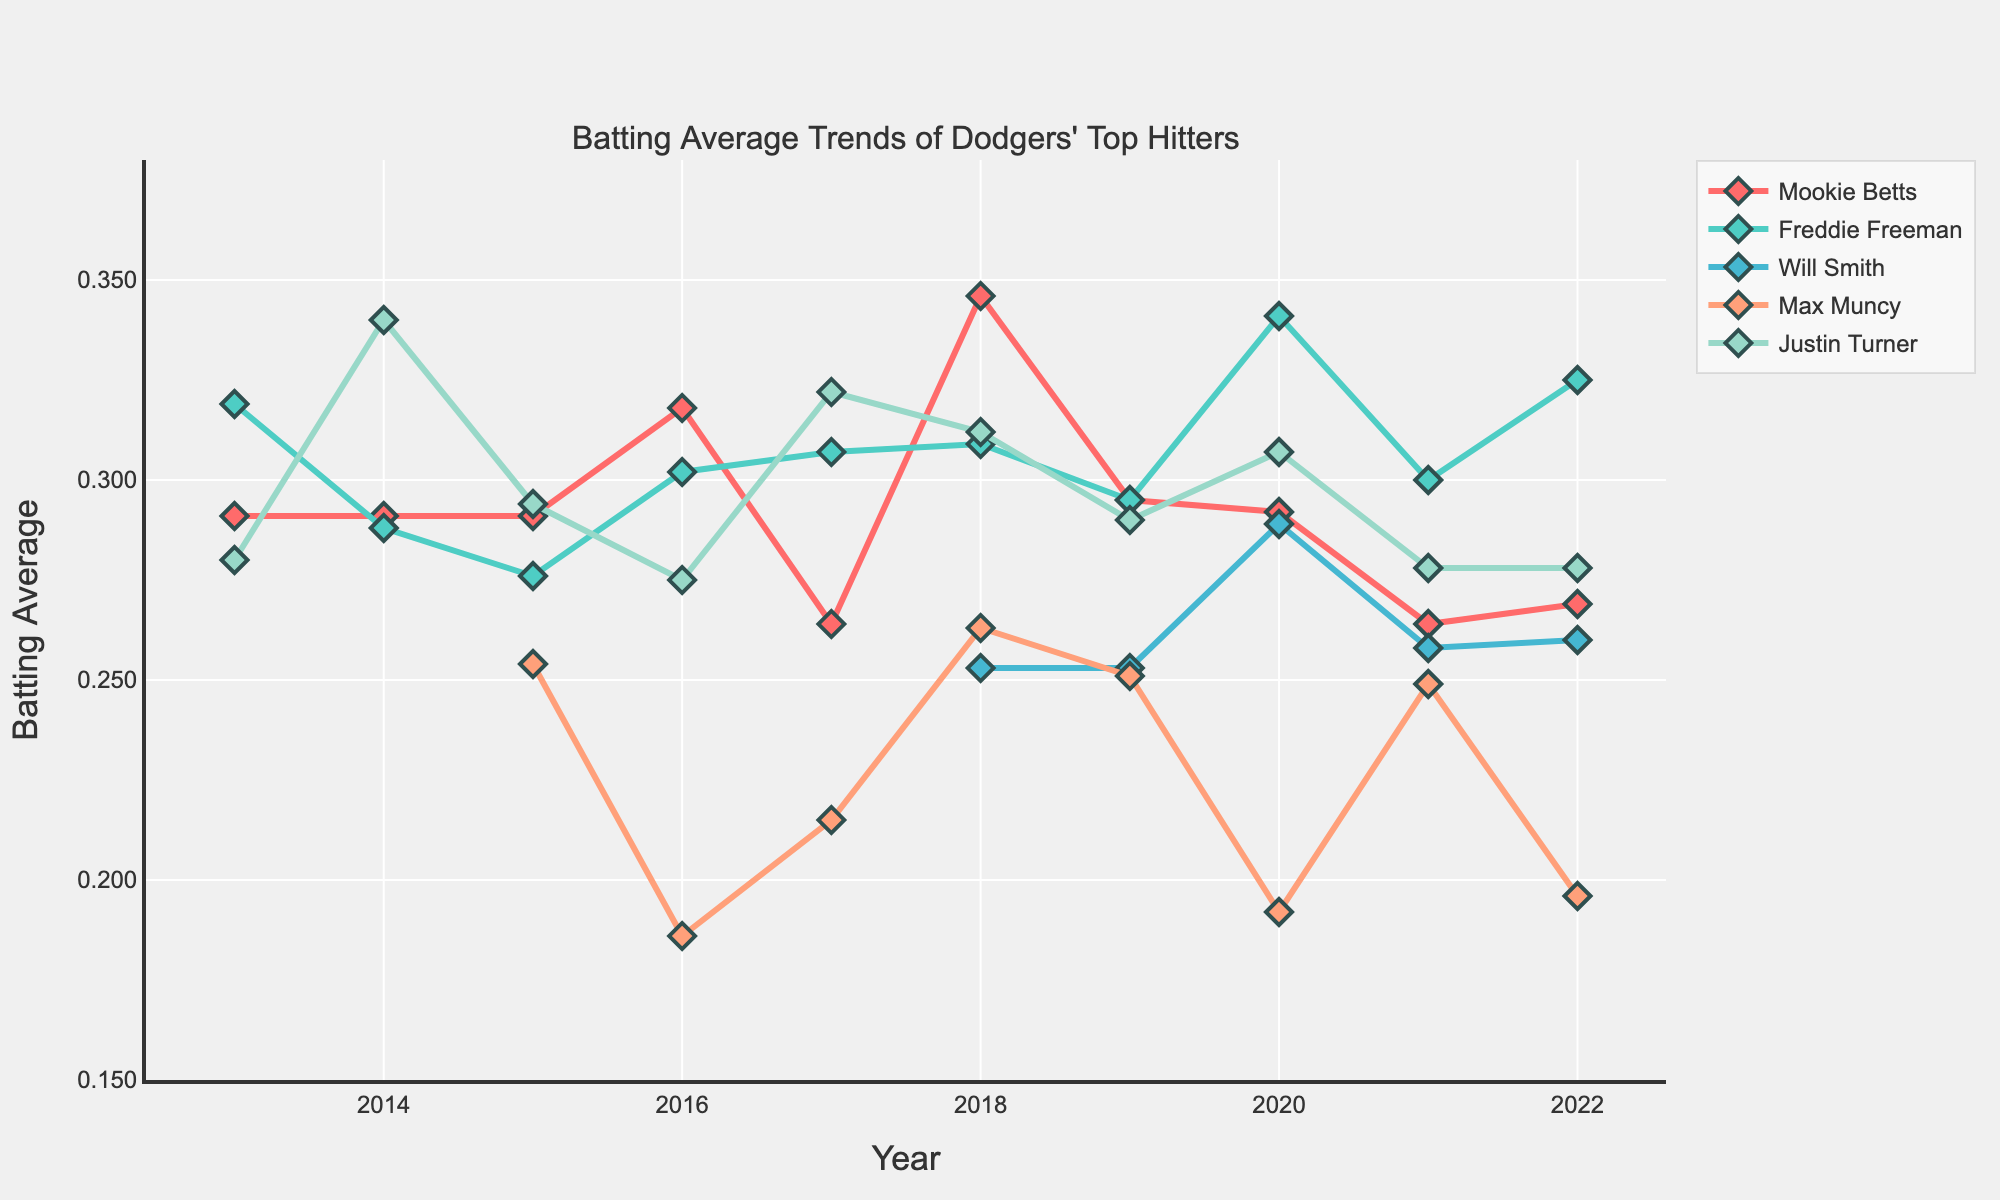What is the trend of Freddie Freeman's batting average over the past 10 seasons? To determine the trend, observe Freddie Freeman's batting average from 2013 to 2022. His average starts at 0.319 in 2013, fluctuating slightly but generally showing an upward trend, especially notable in 2020 where he reaches 0.341.
Answer: Generally increasing In which year did Max Muncy have the lowest batting average? By tracing the line corresponding to Max Muncy, it can be seen that 2016 has the lowest batting average of 0.186.
Answer: 2016 How does Mookie Betts’ average in 2018 compare to his average in 2022? Mookie Betts' average in 2018 is 0.346, while in 2022 it is 0.269. Comparing these, 2018's average is significantly higher.
Answer: 2018 is higher Which player had the highest single-season batting average in the provided data, and in which year? By examining the lines, Justin Turner in 2014 stands out with a batting average of 0.340.
Answer: Justin Turner in 2014 What is the average batting average of Justin Turner over the 10 seasons? Sum Justin Turner's batting averages from 2013 to 2022 and divide by 10. (0.280 + 0.340 + 0.294 + 0.275 + 0.322 + 0.312 + 0.290 + 0.307 + 0.278 + 0.278) / 10 = 3.076 / 10 = 0.308
Answer: 0.308 Compare the batting average trends of Will Smith and Max Muncy from 2018 to 2022. Will Smith's average starts at 0.253 in 2018 and slightly increases to 0.260 in 2022. Max Muncy's average starts at 0.263 in 2018 and decreases to 0.196 in 2022. Will Smith's trend is relatively stable compared to the significant decline in Max Muncy's trend.
Answer: Will Smith is more stable, Max Muncy decreases Between Mookie Betts and Justin Turner, who had a higher batting average in 2020? Referring to the 2020 data points, Betts has an average of 0.292, while Turner has 0.307. Justin Turner has the higher average.
Answer: Justin Turner Which player shows the most variability in batting averages over the 10 seasons, as viewed from the graph? To determine variability, observe the range between the maximum and minimum batting averages for each player. Justin Turner and Freddie Freeman display notable variability. However, Mookie Betts varies the least due to a range mostly between 0.260 and 0.350.
Answer: Justin Turner or Freddie Freeman How does the batting average of Freddie Freeman in 2013 compare to his average in 2022? Freddie Freeman's batting average in 2013 is 0.319, and in 2022 it rises to 0.325.
Answer: 2022 is higher 